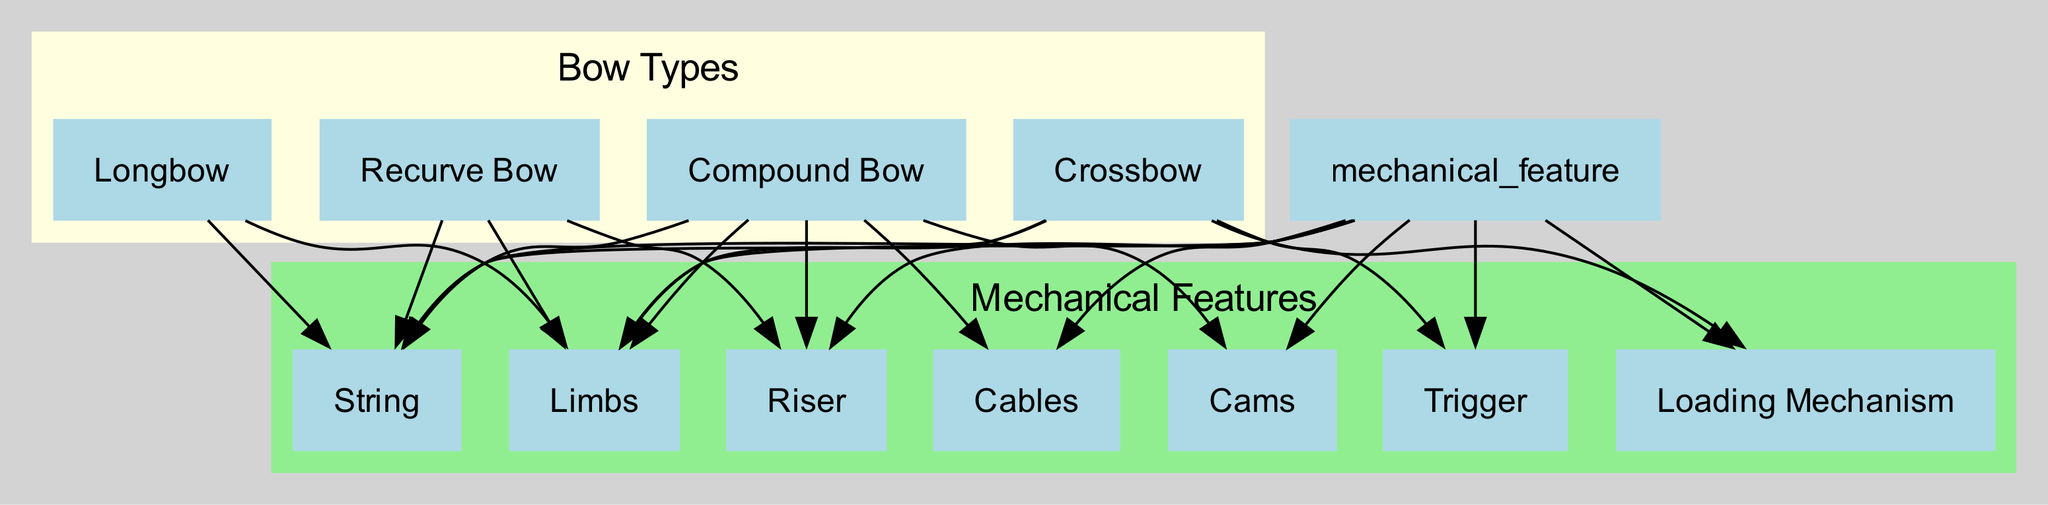What are the four types of bows mentioned in the diagram? The diagram lists four types of bows: recurve bow, compound bow, longbow, and crossbow. Each is clearly labeled within the "Bow Types" subgraph.
Answer: recurve bow, compound bow, longbow, crossbow Which bow type has a loading mechanism as a mechanical feature? The loading mechanism is specifically connected to the crossbow in the diagram as a unique feature. Looking at the edges stemming from the crossbow, there's a direct relationship to the loading mechanism.
Answer: crossbow How many mechanical features are represented in the diagram? The diagram includes six distinct mechanical features: limbs, cables, cams, string, riser, trigger, and loading mechanism. Counting these nodes under the 'Mechanical Features' subgraph gives us a total of six.
Answer: six What connections does the compound bow have to mechanical features? The compound bow connects to four mechanical features: limbs, cables, cams, and string. The relationships between the compound bow and its features can be traced through the edges exiting from the compound bow node.
Answer: limbs, cables, cams, string Which bow type does not include cables in its mechanical features? The longbow and recurve bow are both listed without cables as a mechanical feature in their respective connections. The edges for each bow type show what features they are related to, confirming that cables are absent for these two.
Answer: longbow, recurve bow What mechanical features are shared among all four types of bows? The diagram indicates that all four types of bows (recurve, compound, longbow, crossbow) share the mechanical features of limbs and string. By examining the connection lines for each bow type, these are revealed as commonalities.
Answer: limbs, string 